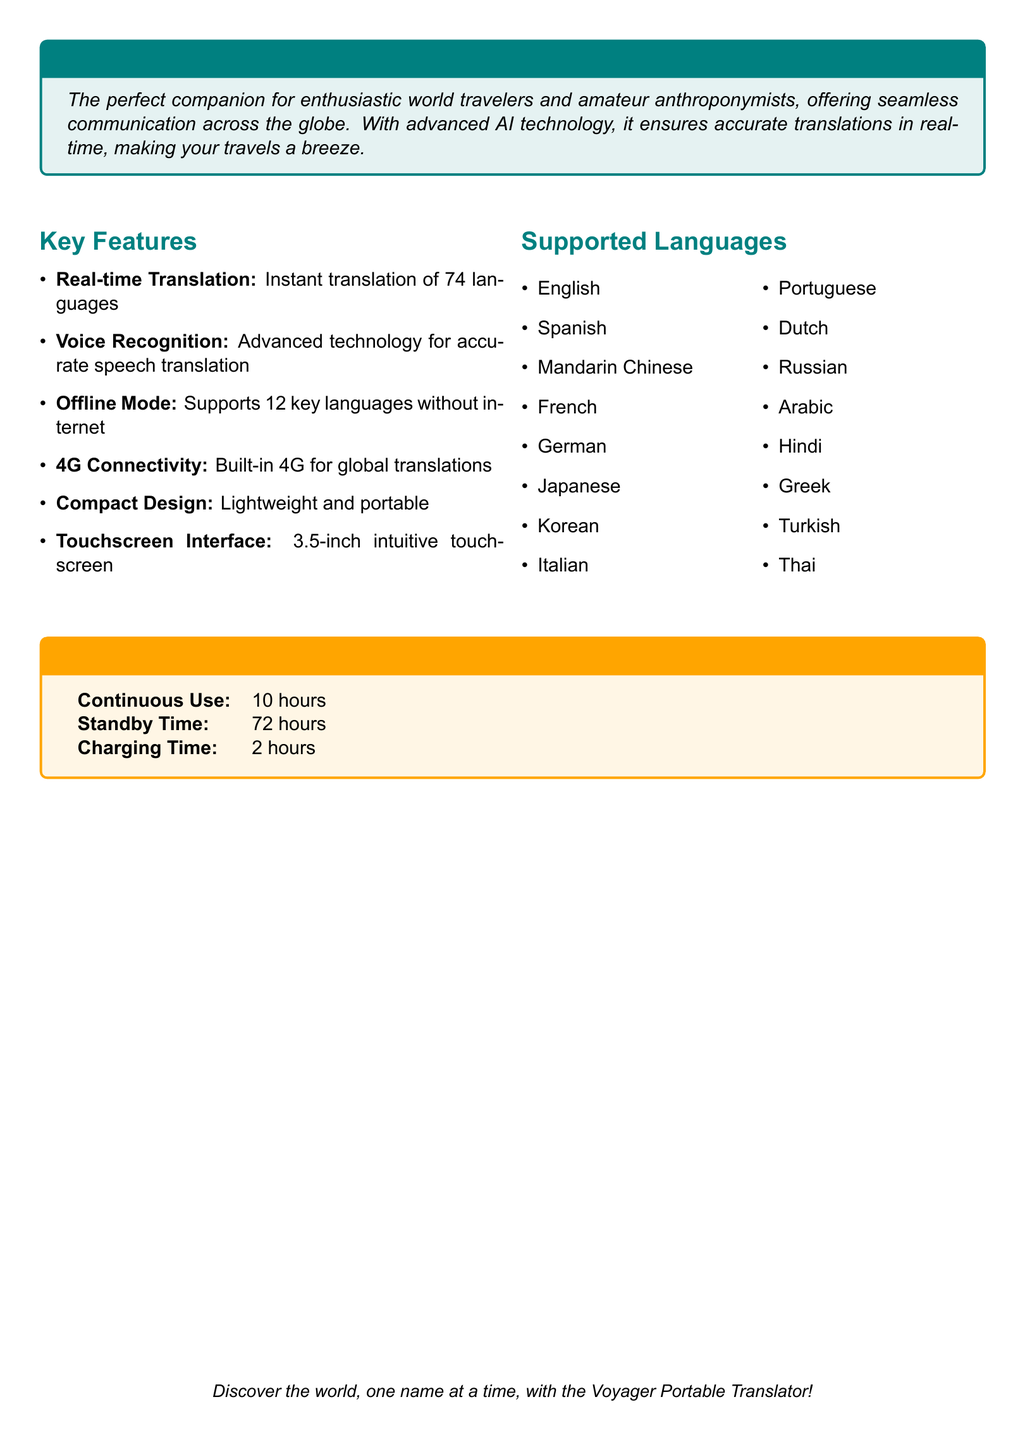What is the product name? The product name is mentioned in the title section of the document.
Answer: Voyager Portable Translator How many languages does it support in real-time? The number of languages supported in real-time is stated in the key features section of the document.
Answer: 74 languages What is the battery life for continuous use? The document lists the continuous use battery life in the battery life section.
Answer: 10 hours Which mode allows offline translation? The offline mode is specified in the key features section of the document.
Answer: Offline Mode What screen size does the translator have? The screen size is provided in the key features section regarding the touchscreen interface.
Answer: 3.5-inch How long is the standby time? The standby time is detailed in the battery life section of the document.
Answer: 72 hours What type of connectivity does the translator have? The document specifies the type of connectivity in the key features section.
Answer: 4G Connectivity Is there a requirement for internet for all supported languages? This can be inferred by comparing the offline mode against the total languages supported.
Answer: No 